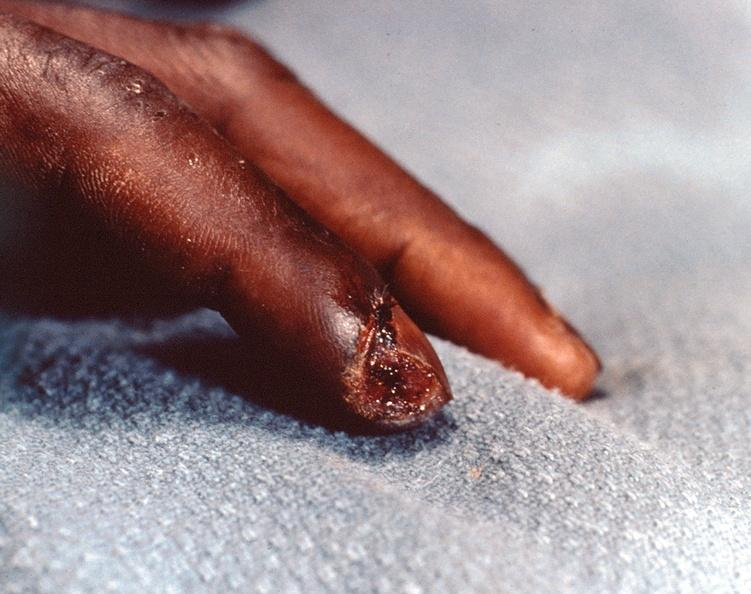what are present?
Answer the question using a single word or phrase. Extremities 